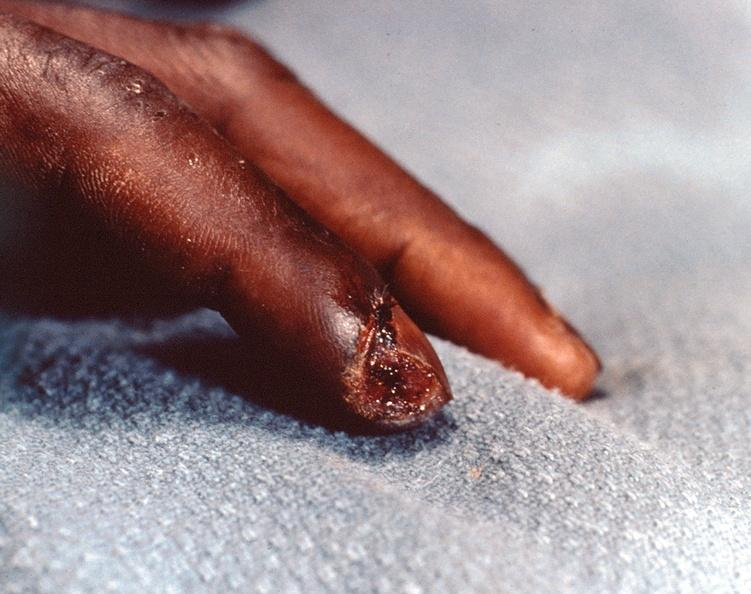what are present?
Answer the question using a single word or phrase. Extremities 